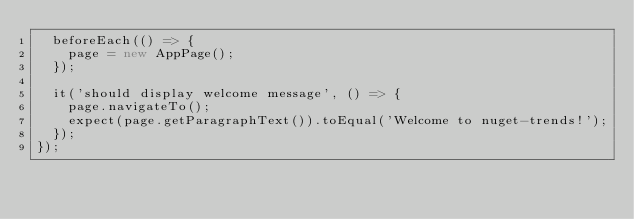<code> <loc_0><loc_0><loc_500><loc_500><_TypeScript_>  beforeEach(() => {
    page = new AppPage();
  });

  it('should display welcome message', () => {
    page.navigateTo();
    expect(page.getParagraphText()).toEqual('Welcome to nuget-trends!');
  });
});
</code> 